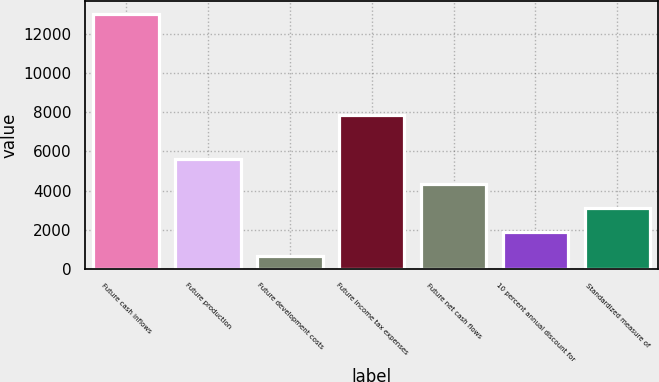Convert chart to OTSL. <chart><loc_0><loc_0><loc_500><loc_500><bar_chart><fcel>Future cash inflows<fcel>Future production<fcel>Future development costs<fcel>Future income tax expenses<fcel>Future net cash flows<fcel>10 percent annual discount for<fcel>Standardized measure of<nl><fcel>13044<fcel>5600.4<fcel>638<fcel>7871<fcel>4359.8<fcel>1878.6<fcel>3119.2<nl></chart> 